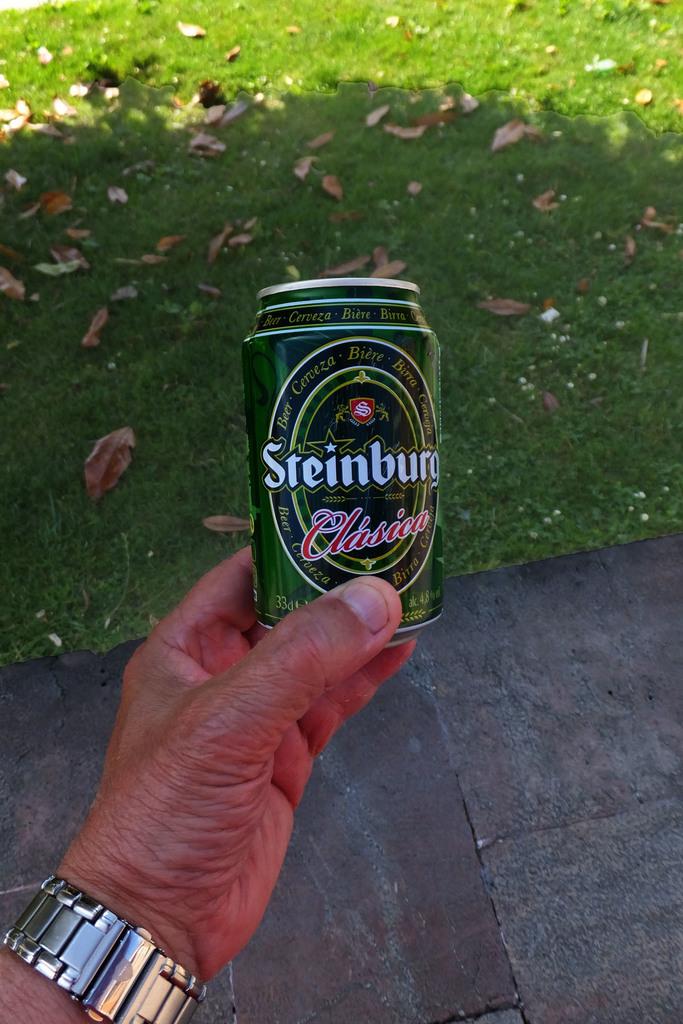What brand of beer is that?
Your response must be concise. Steinburg. What percent alcohol is this?
Your response must be concise. 4.8. 